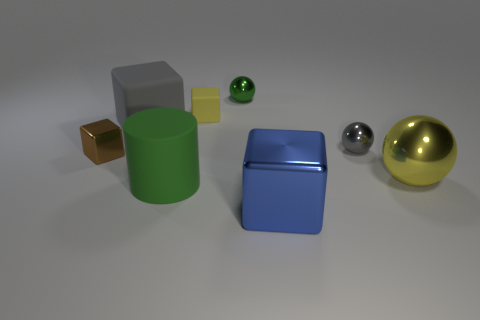Subtract all red blocks. Subtract all blue balls. How many blocks are left? 4 Add 1 blue objects. How many objects exist? 9 Subtract all balls. How many objects are left? 5 Subtract 0 red blocks. How many objects are left? 8 Subtract all shiny balls. Subtract all small brown metallic things. How many objects are left? 4 Add 2 tiny gray shiny balls. How many tiny gray shiny balls are left? 3 Add 6 large green rubber cylinders. How many large green rubber cylinders exist? 7 